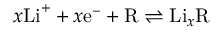Convert formula to latex. <formula><loc_0><loc_0><loc_500><loc_500>x L i ^ { + } + x e ^ { - } + R \rightleftharpoons L i _ { x } R</formula> 